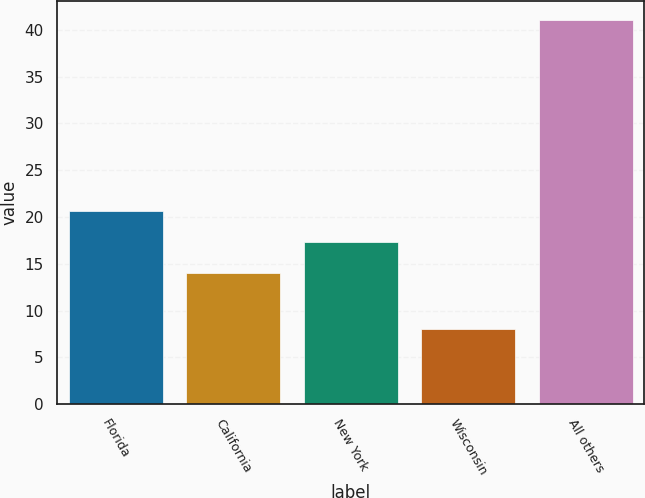Convert chart to OTSL. <chart><loc_0><loc_0><loc_500><loc_500><bar_chart><fcel>Florida<fcel>California<fcel>New York<fcel>Wisconsin<fcel>All others<nl><fcel>20.6<fcel>14<fcel>17.3<fcel>8<fcel>41<nl></chart> 